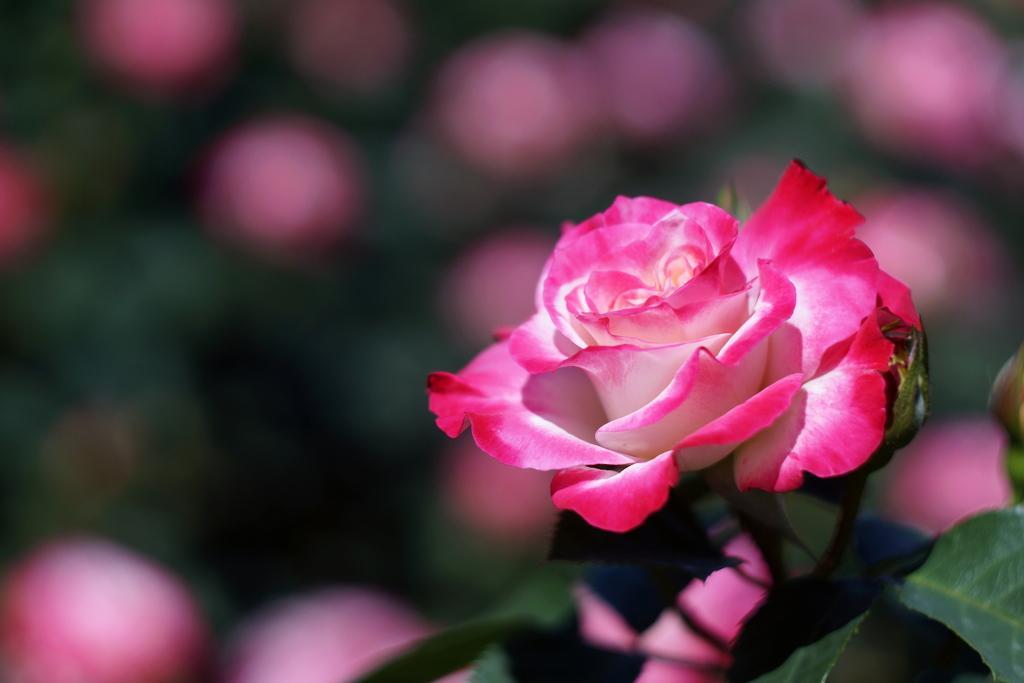In one or two sentences, can you explain what this image depicts? On the right side of the image there is a rose plant and we can see a rose which is in pink color. 